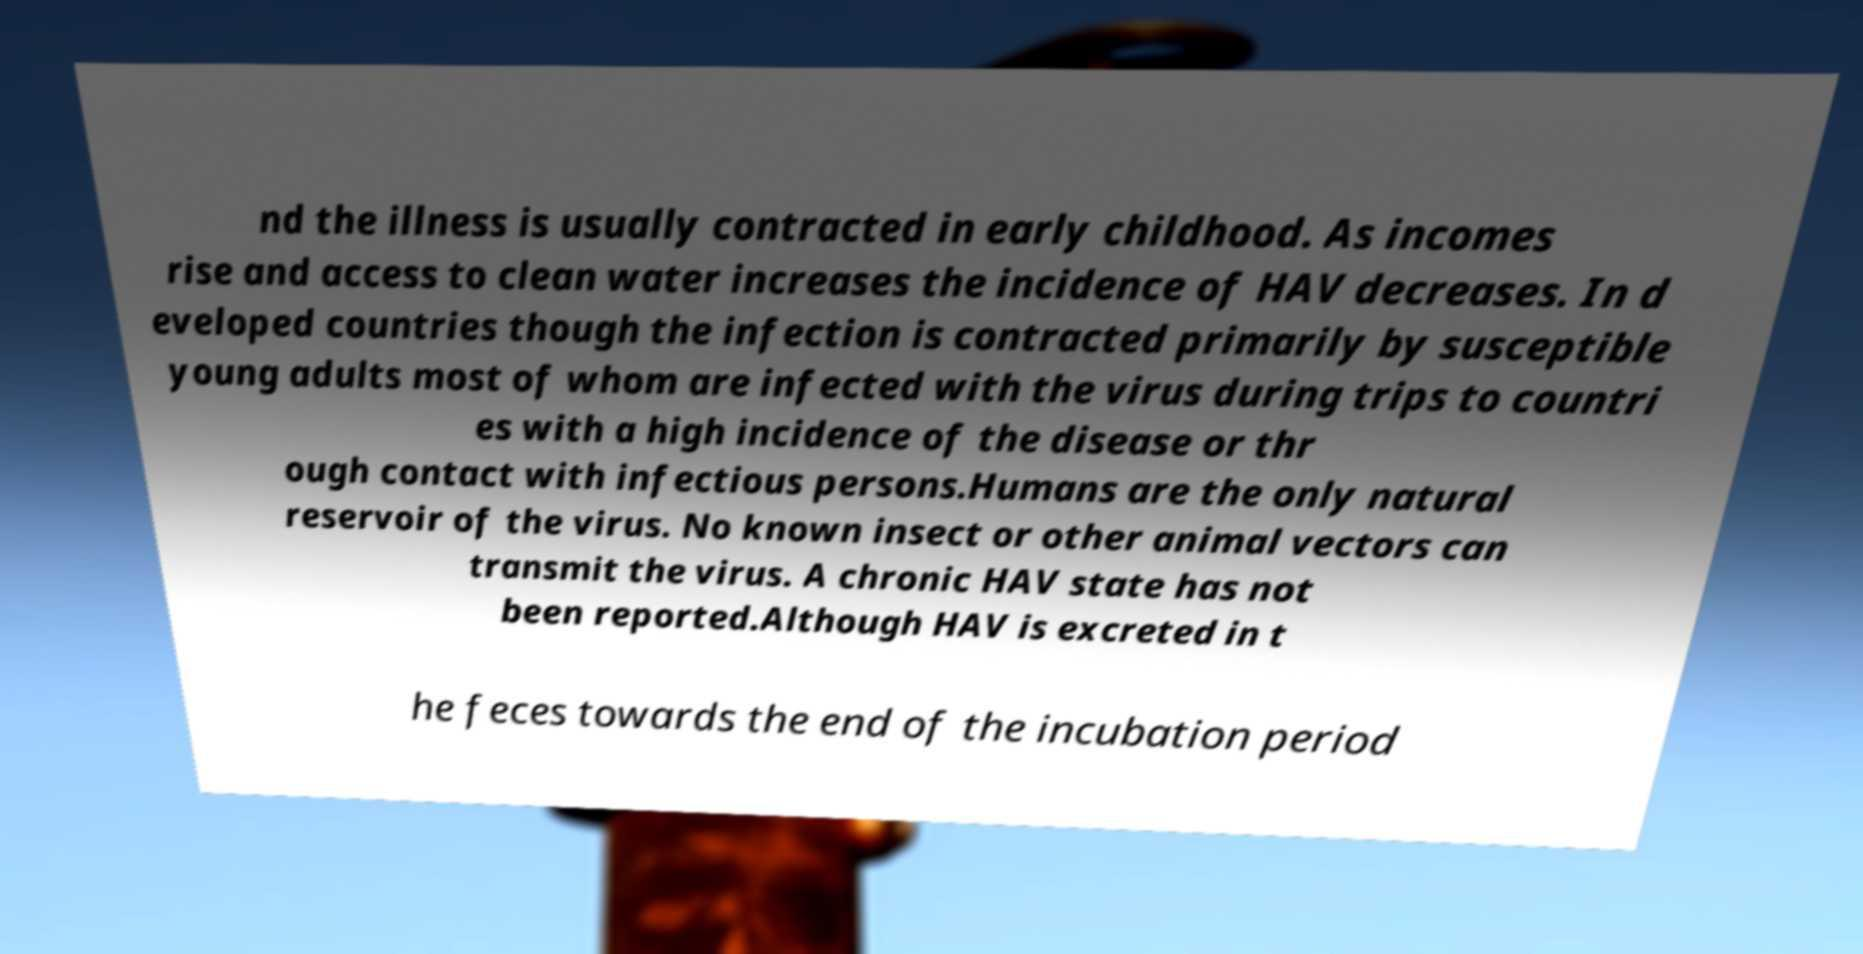There's text embedded in this image that I need extracted. Can you transcribe it verbatim? nd the illness is usually contracted in early childhood. As incomes rise and access to clean water increases the incidence of HAV decreases. In d eveloped countries though the infection is contracted primarily by susceptible young adults most of whom are infected with the virus during trips to countri es with a high incidence of the disease or thr ough contact with infectious persons.Humans are the only natural reservoir of the virus. No known insect or other animal vectors can transmit the virus. A chronic HAV state has not been reported.Although HAV is excreted in t he feces towards the end of the incubation period 